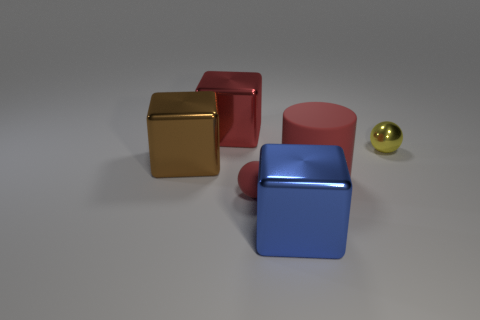Subtract all red cubes. How many cubes are left? 2 Add 3 big brown metallic blocks. How many objects exist? 9 Subtract all balls. How many objects are left? 4 Subtract all tiny yellow things. Subtract all tiny red objects. How many objects are left? 4 Add 5 large red things. How many large red things are left? 7 Add 1 cyan metallic cylinders. How many cyan metallic cylinders exist? 1 Subtract 0 purple balls. How many objects are left? 6 Subtract 1 spheres. How many spheres are left? 1 Subtract all red balls. Subtract all cyan cylinders. How many balls are left? 1 Subtract all yellow spheres. How many red blocks are left? 1 